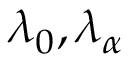Convert formula to latex. <formula><loc_0><loc_0><loc_500><loc_500>\lambda _ { 0 } , \lambda _ { \alpha }</formula> 